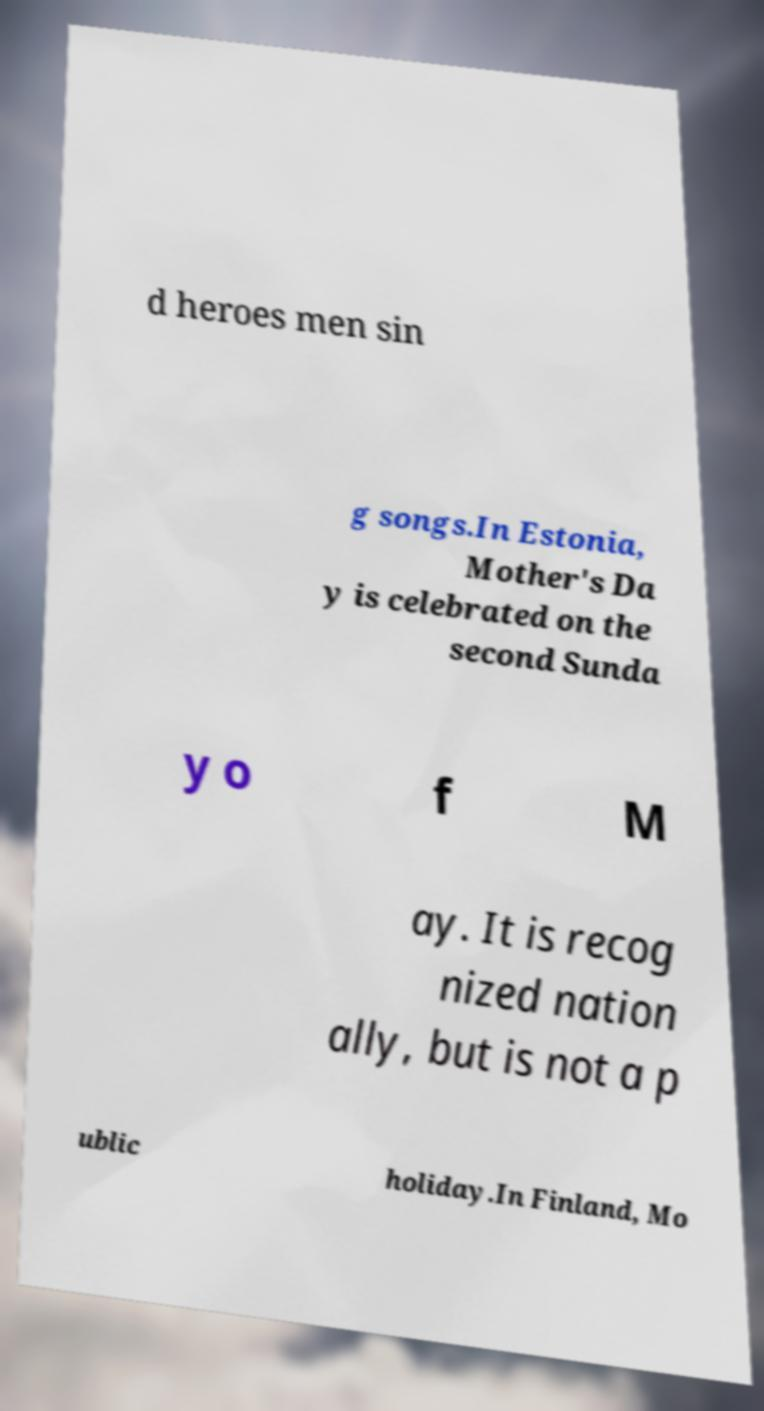Please read and relay the text visible in this image. What does it say? d heroes men sin g songs.In Estonia, Mother's Da y is celebrated on the second Sunda y o f M ay. It is recog nized nation ally, but is not a p ublic holiday.In Finland, Mo 